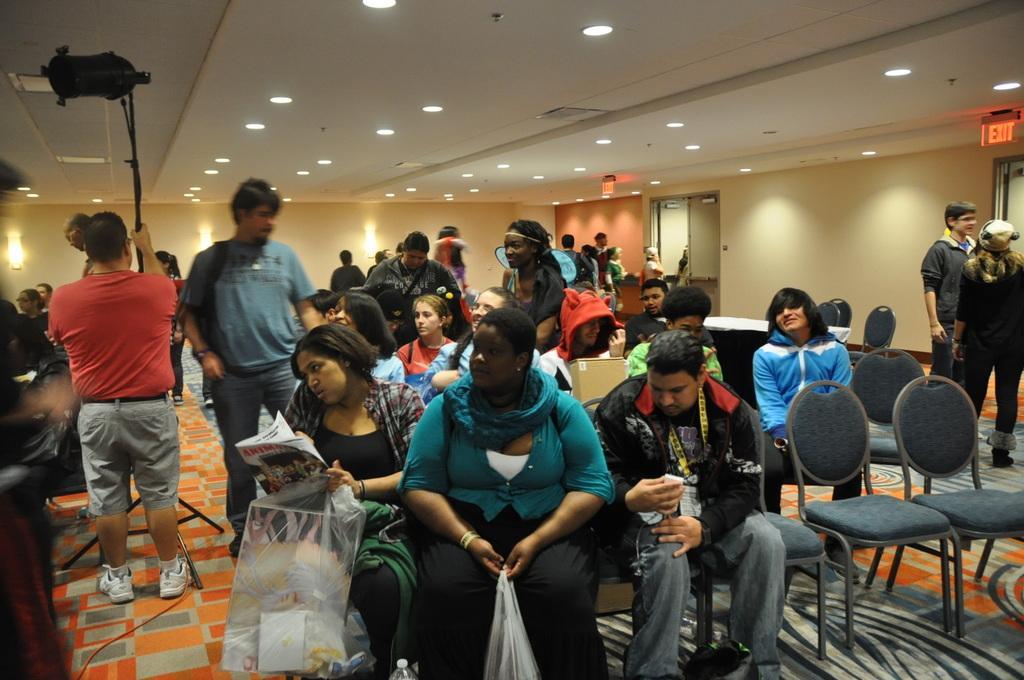Please provide a concise description of this image. In the image we can see group of persons were sitting on the chair and holding plastic covers,books and box. On the right we can see two persons were standing. On the left we can see again two persons were standing and holding camera. In the background there is a wall,door,empty chairs,table and few persons were standing. 